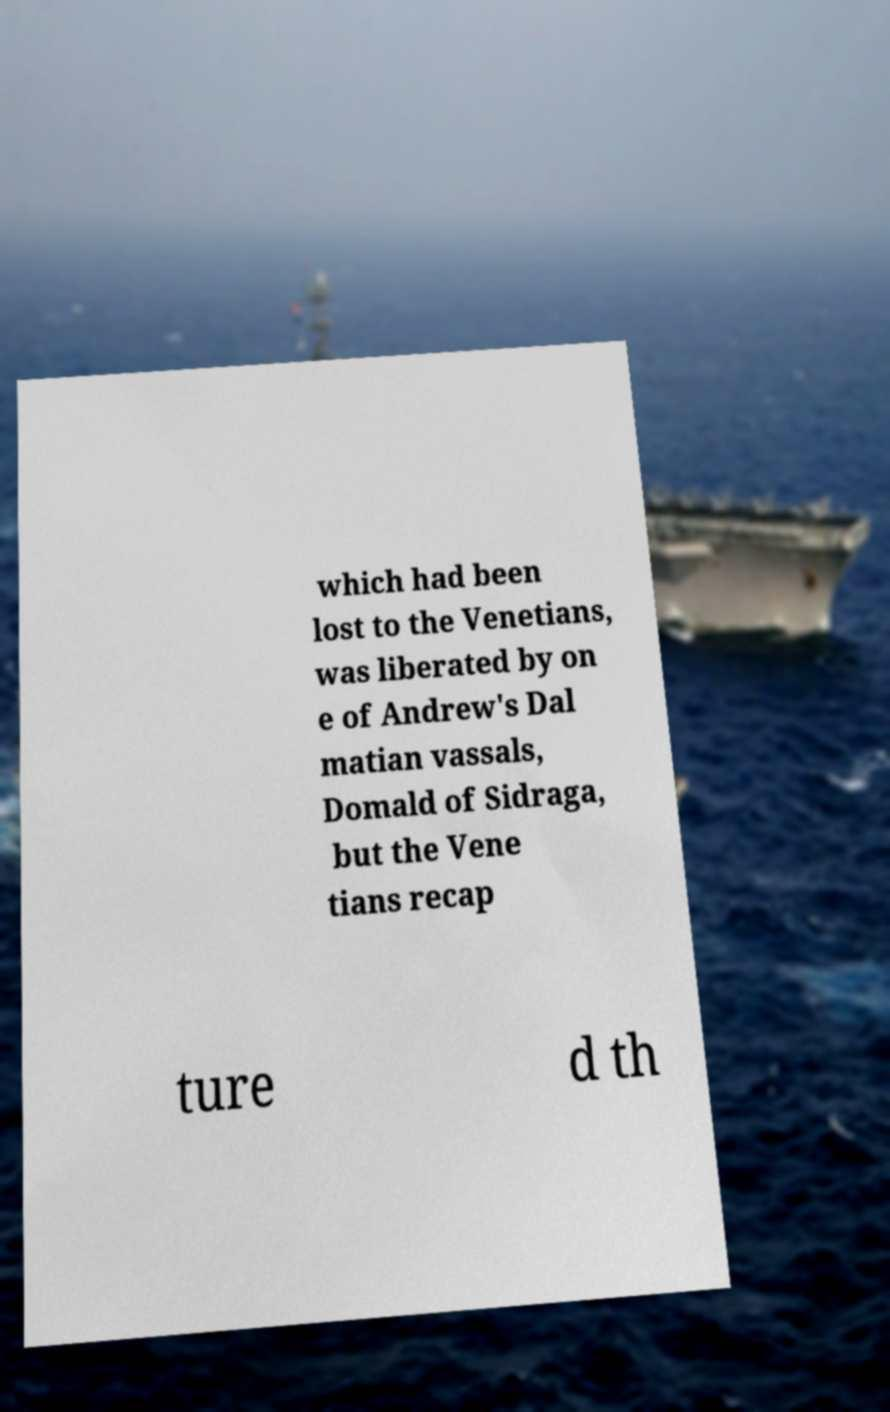For documentation purposes, I need the text within this image transcribed. Could you provide that? which had been lost to the Venetians, was liberated by on e of Andrew's Dal matian vassals, Domald of Sidraga, but the Vene tians recap ture d th 